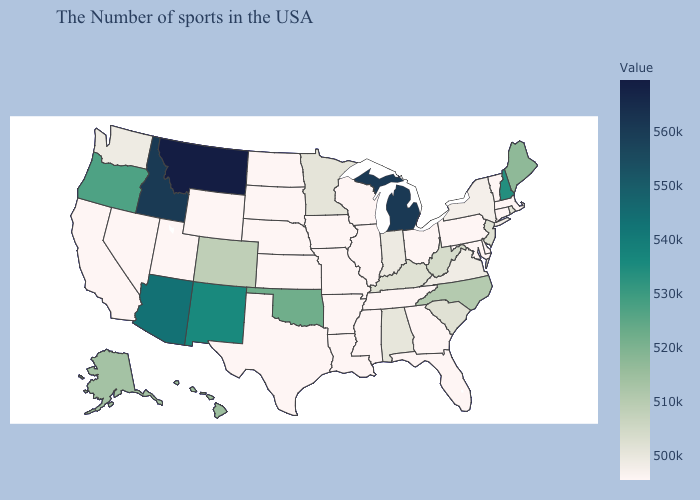Does New Mexico have a higher value than Montana?
Give a very brief answer. No. Does the map have missing data?
Concise answer only. No. Does Alaska have the lowest value in the USA?
Quick response, please. No. Among the states that border Pennsylvania , does Ohio have the lowest value?
Give a very brief answer. Yes. Which states have the lowest value in the USA?
Short answer required. Massachusetts, Vermont, Connecticut, Delaware, Maryland, Pennsylvania, Ohio, Florida, Georgia, Tennessee, Wisconsin, Illinois, Mississippi, Louisiana, Missouri, Arkansas, Iowa, Kansas, Nebraska, Texas, South Dakota, North Dakota, Wyoming, Utah, Nevada, California. Does Connecticut have the lowest value in the USA?
Give a very brief answer. Yes. Does Minnesota have a higher value than Colorado?
Quick response, please. No. 